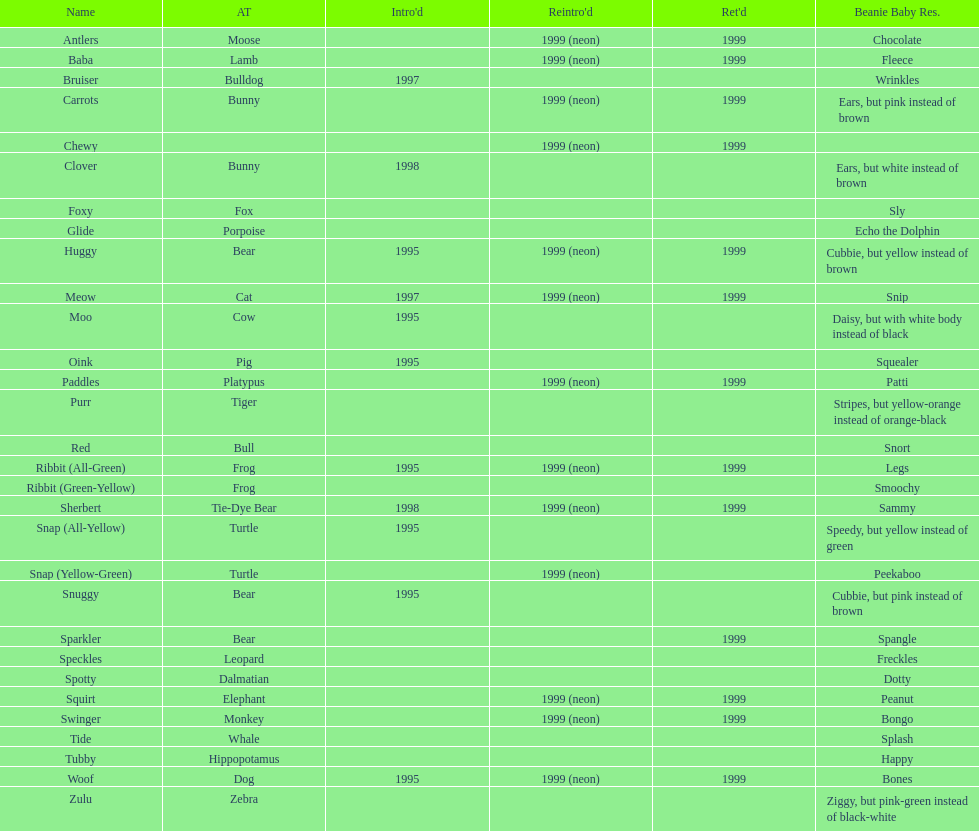What is the name of the last pillow pal on this chart? Zulu. 